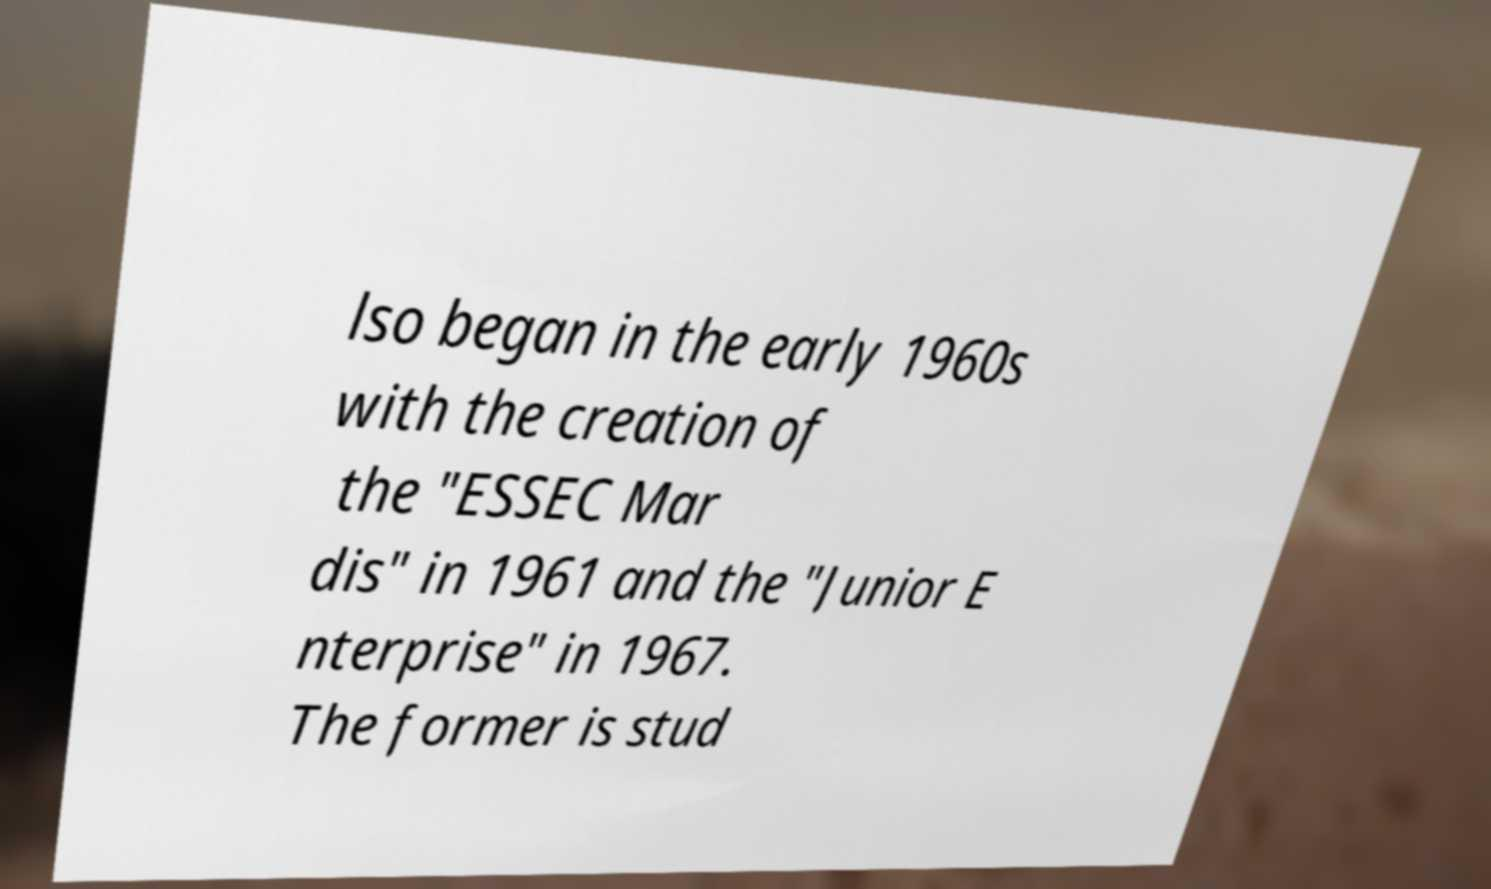Please identify and transcribe the text found in this image. lso began in the early 1960s with the creation of the "ESSEC Mar dis" in 1961 and the "Junior E nterprise" in 1967. The former is stud 